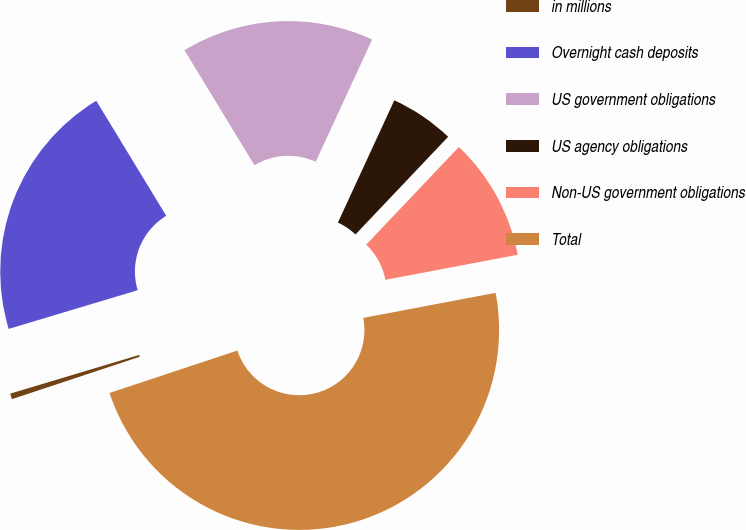<chart> <loc_0><loc_0><loc_500><loc_500><pie_chart><fcel>in millions<fcel>Overnight cash deposits<fcel>US government obligations<fcel>US agency obligations<fcel>Non-US government obligations<fcel>Total<nl><fcel>0.46%<fcel>20.94%<fcel>15.58%<fcel>5.2%<fcel>9.94%<fcel>47.88%<nl></chart> 